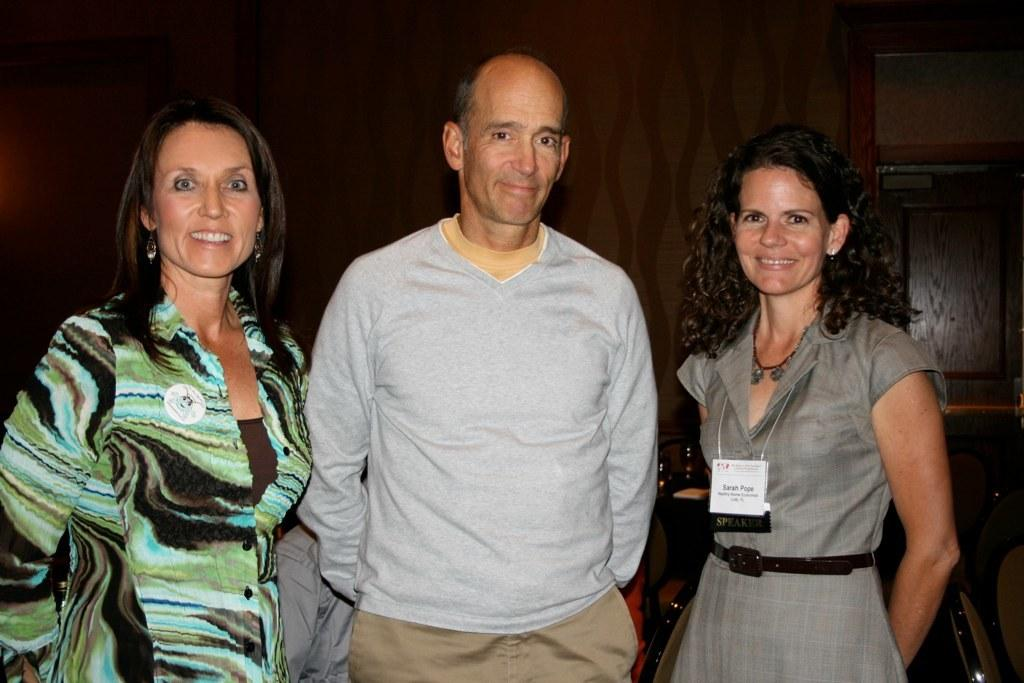How many people are present in the image? There are three people in the image: two ladies and a guy. What are the individuals in the image doing? All three individuals are standing. Can you describe any distinguishing features of one of the ladies? One of the ladies has a tag. What type of recess can be seen in the image? There is no recess present in the image. What is the guy rubbing against in the image? There is no indication in the image of the guy rubbing against anything. 